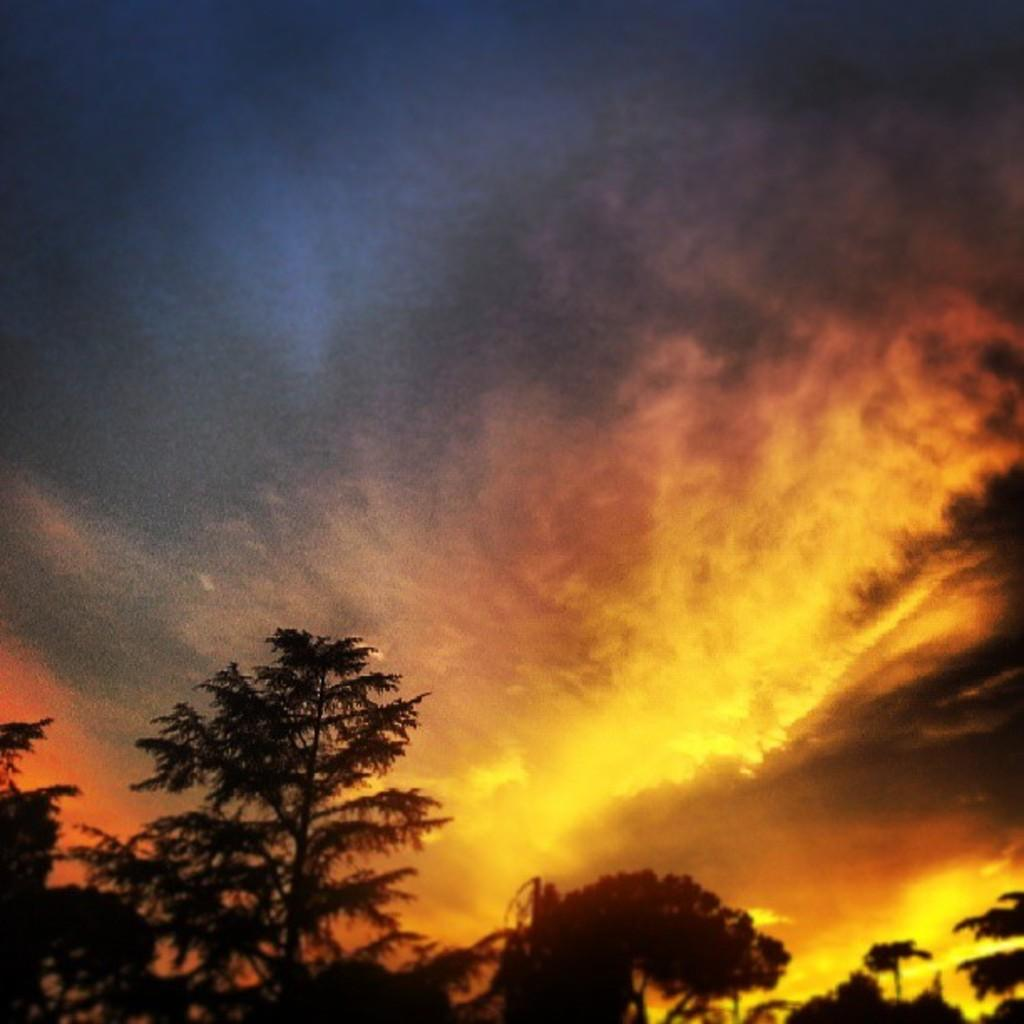What type of natural elements can be seen in the image? There are trees in the image. What else is visible in the sky in the image? There are clouds in the image. What type of pancake is being served to the partner in the image? There is no pancake or partner present in the image. What is the result of the addition of two numbers in the image? There is no mathematical operation or result visible in the image. 